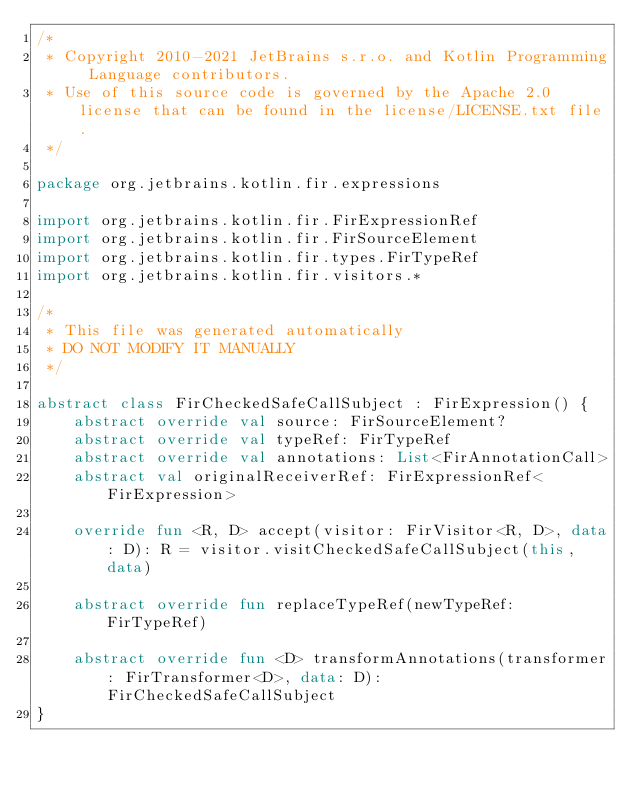<code> <loc_0><loc_0><loc_500><loc_500><_Kotlin_>/*
 * Copyright 2010-2021 JetBrains s.r.o. and Kotlin Programming Language contributors.
 * Use of this source code is governed by the Apache 2.0 license that can be found in the license/LICENSE.txt file.
 */

package org.jetbrains.kotlin.fir.expressions

import org.jetbrains.kotlin.fir.FirExpressionRef
import org.jetbrains.kotlin.fir.FirSourceElement
import org.jetbrains.kotlin.fir.types.FirTypeRef
import org.jetbrains.kotlin.fir.visitors.*

/*
 * This file was generated automatically
 * DO NOT MODIFY IT MANUALLY
 */

abstract class FirCheckedSafeCallSubject : FirExpression() {
    abstract override val source: FirSourceElement?
    abstract override val typeRef: FirTypeRef
    abstract override val annotations: List<FirAnnotationCall>
    abstract val originalReceiverRef: FirExpressionRef<FirExpression>

    override fun <R, D> accept(visitor: FirVisitor<R, D>, data: D): R = visitor.visitCheckedSafeCallSubject(this, data)

    abstract override fun replaceTypeRef(newTypeRef: FirTypeRef)

    abstract override fun <D> transformAnnotations(transformer: FirTransformer<D>, data: D): FirCheckedSafeCallSubject
}
</code> 